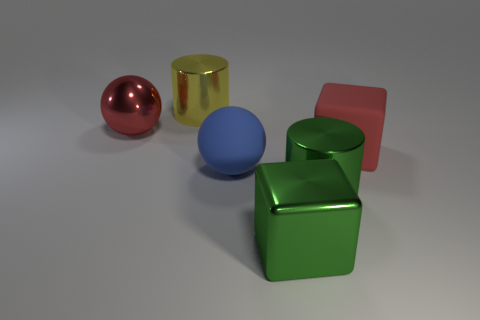What color is the large metallic object that is to the left of the large green cylinder and to the right of the big yellow cylinder?
Offer a very short reply. Green. Do the large green cylinder and the sphere that is to the left of the yellow metal thing have the same material?
Your answer should be compact. Yes. Are there any other things of the same color as the large rubber ball?
Your response must be concise. No. Is the material of the green block that is to the right of the blue rubber sphere the same as the big red thing that is behind the matte block?
Keep it short and to the point. Yes. What material is the object that is both right of the metallic cube and left of the red block?
Offer a very short reply. Metal. There is a large yellow metal object; does it have the same shape as the red thing right of the metal ball?
Offer a terse response. No. There is a big red thing right of the large matte thing on the left side of the big red thing in front of the metal sphere; what is it made of?
Make the answer very short. Rubber. How many other things are there of the same size as the yellow object?
Keep it short and to the point. 5. Is the big metallic ball the same color as the rubber block?
Provide a succinct answer. Yes. There is a red object on the right side of the big metallic cylinder that is in front of the large red shiny object; what number of large red rubber blocks are to the left of it?
Your answer should be compact. 0. 